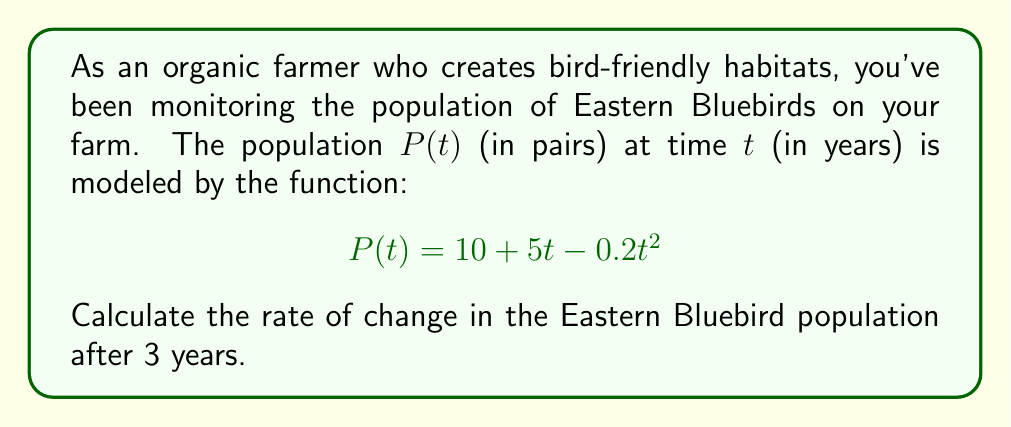Solve this math problem. To find the rate of change in the bird population at a specific time, we need to calculate the derivative of the population function and evaluate it at the given time.

Step 1: Find the derivative of $P(t)$.
$$P(t) = 10 + 5t - 0.2t^2$$
$$P'(t) = 5 - 0.4t$$

Step 2: Evaluate the derivative at $t = 3$ years.
$$P'(3) = 5 - 0.4(3)$$
$$P'(3) = 5 - 1.2$$
$$P'(3) = 3.8$$

The rate of change is 3.8 pairs of Eastern Bluebirds per year after 3 years.

Step 3: Interpret the result.
Since the rate of change is positive, the Eastern Bluebird population is still increasing after 3 years, but at a slower rate than initially. This information can help the farmer assess the effectiveness of their bird-friendly habitat and make decisions about future conservation efforts.
Answer: 3.8 pairs/year 